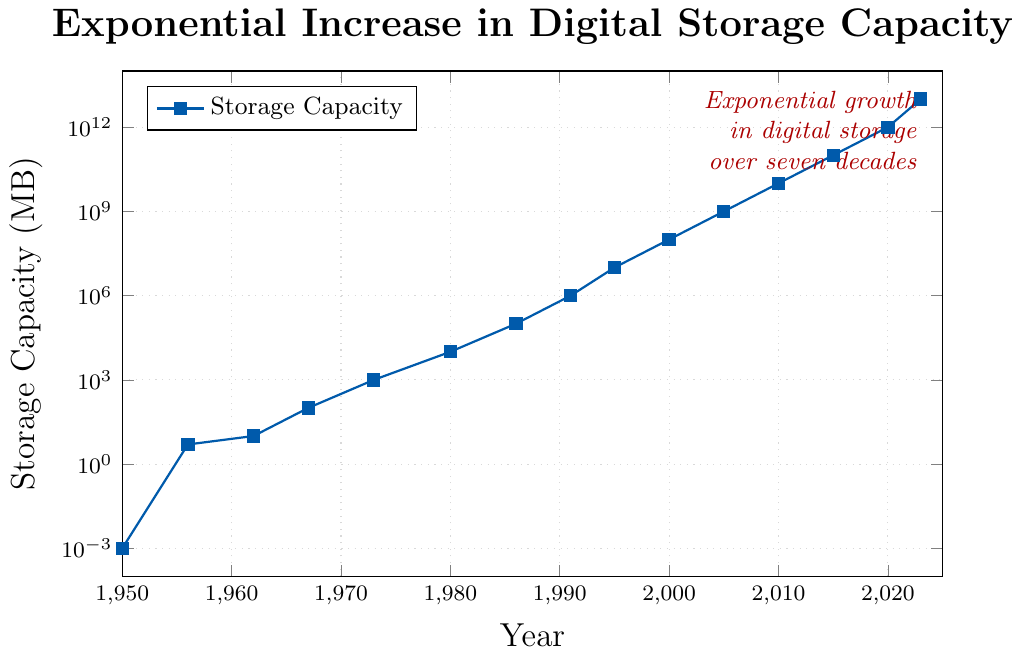What is the storage capacity in MB in the year 2000? Locate the year 2000 on the x-axis and find the corresponding value on the y-axis. In 2000, the storage capacity is 100,000,000 MB as indicated by the data points in the figure.
Answer: 100,000,000 By how many orders of magnitude did the storage capacity increase from 1950 to 2023? Calculate the difference in magnitudes: log10(10^13) - log10(10^-3) = 13 - (-3) = 16. The storage capacity increased by 16 orders of magnitude.
Answer: 16 In which year did the storage capacity reach 1,000 MB? Locate the y-axis value of 1,000 MB and identify the corresponding year on the x-axis. The figure shows that it was achieved in 1973.
Answer: 1973 How many years did it take for the storage capacity to grow from 5 MB to 10,000 MB? Find the years corresponding to 5 MB and 10,000 MB, which are 1956 and 1980 respectively. Then calculate the difference: 1980 - 1956 = 24 years.
Answer: 24 Compare the storage capacity in 1986 and 2000. Which year had higher storage capacity? By how much? The storage capacity in 1986 was 100,000 MB, and in 2000, it was 100,000,000 MB. Subtract the two: 100,000,000 - 100,000 = 99,900,000 MB. 2000 had a higher storage capacity by 99,900,000 MB.
Answer: 2000, by 99,900,000 MB What is the average storage capacity from 1950 to 1973? Identify the values for the years 1950, 1956, 1962, 1967, and 1973: (0.001 + 5 + 10 + 100 + 1000). Sum these values and divide by 5 to find the average. (0.001 + 5 + 10 + 100 + 1000) / 5 = 111.002 MB.
Answer: 111.002 What trend does the figure depict in digital storage capacity from 1950 to 2023? Observe the general pattern: storage capacity increases exponentially over time, indicated by a steadily rising curve on a log-scale plot.
Answer: Exponential increase When was the first significant jump in storage capacity observed, and by how much did it increase? Identify the large jumps by comparing consecutive points. The first significant jump is between 1950 (0.001 MB) and 1956 (5 MB). Difference: 5 - 0.001 = 4.999 MB.
Answer: 1956, by 4.999 MB 